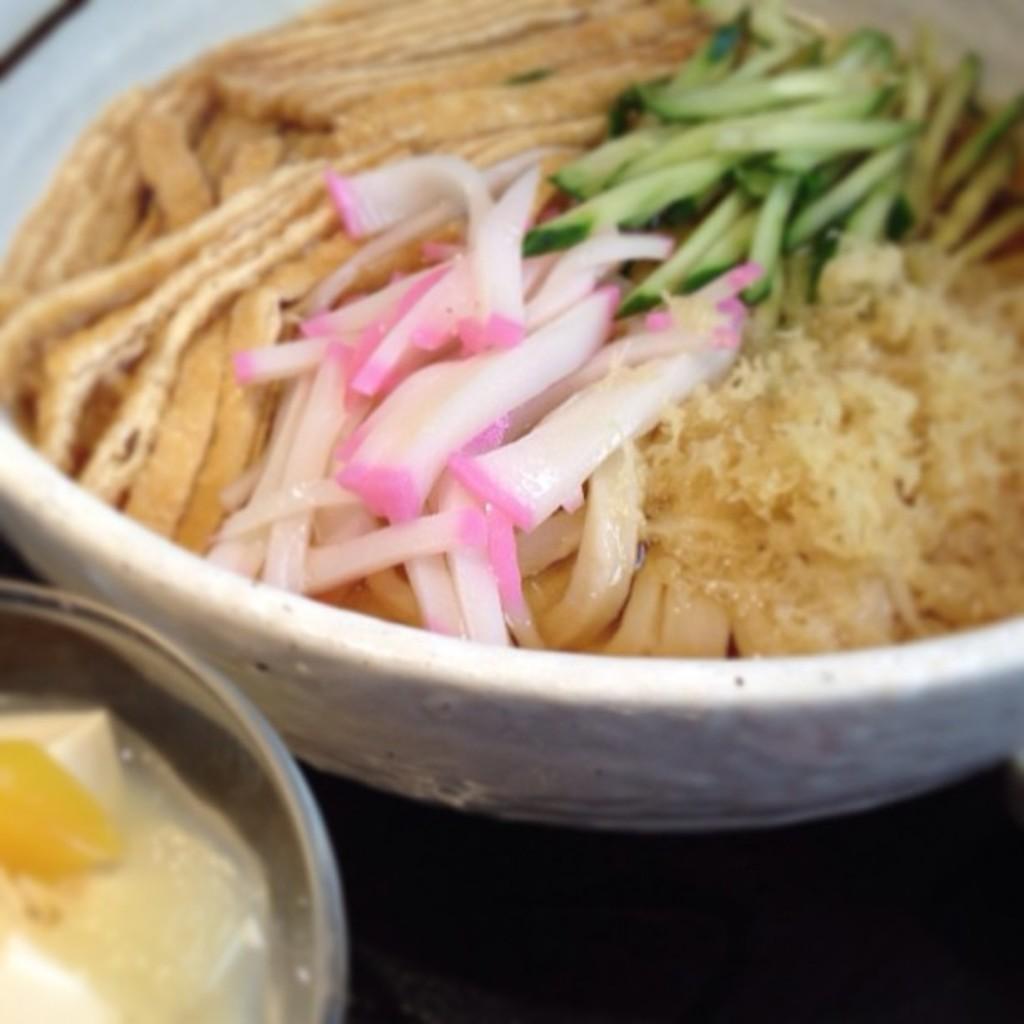Describe this image in one or two sentences. In the image we can see there are food items kept in the bowels and the bowls are kept on the table. 